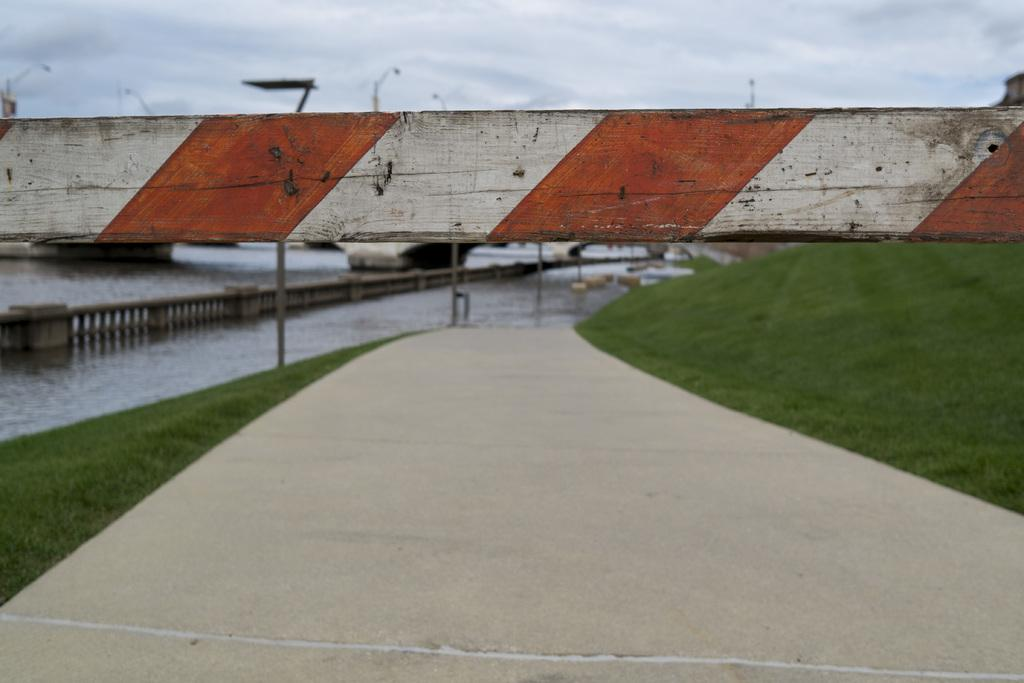What is the main feature of the image? There is a road in the image. What can be seen on the sides of the road? There are grass lawns on the sides of the road. What structure is present in the image? There is a bridge in the image. What is the bridge's relationship to the water in the image? The bridge is partially in the water. What is visible in the background of the image? The sky is visible in the background of the image. Can you hear the voice of the hen on the seashore in the image? There is no hen or seashore present in the image, and therefore no voice can be heard. 